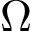<formula> <loc_0><loc_0><loc_500><loc_500>\Omega</formula> 